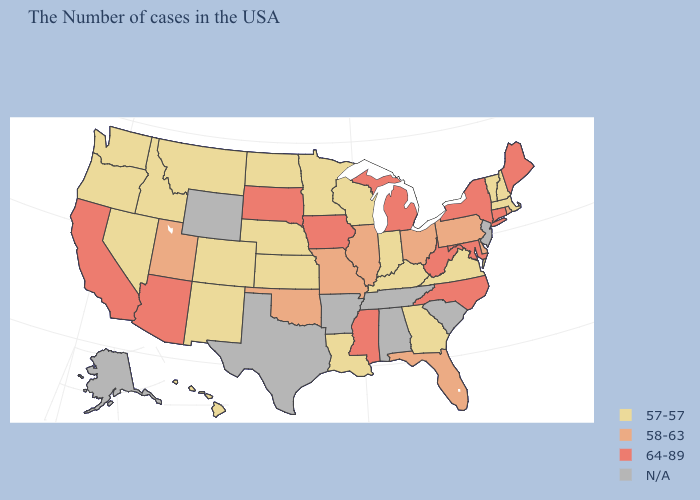Name the states that have a value in the range 64-89?
Answer briefly. Maine, Connecticut, New York, Maryland, North Carolina, West Virginia, Michigan, Mississippi, Iowa, South Dakota, Arizona, California. Name the states that have a value in the range N/A?
Concise answer only. New Jersey, South Carolina, Alabama, Tennessee, Arkansas, Texas, Wyoming, Alaska. What is the value of Minnesota?
Concise answer only. 57-57. Among the states that border Nebraska , does Colorado have the highest value?
Answer briefly. No. Does Montana have the highest value in the USA?
Quick response, please. No. What is the highest value in states that border New Hampshire?
Give a very brief answer. 64-89. Does Arizona have the highest value in the USA?
Quick response, please. Yes. Which states have the lowest value in the MidWest?
Be succinct. Indiana, Wisconsin, Minnesota, Kansas, Nebraska, North Dakota. What is the lowest value in the West?
Keep it brief. 57-57. Name the states that have a value in the range 58-63?
Quick response, please. Rhode Island, Delaware, Pennsylvania, Ohio, Florida, Illinois, Missouri, Oklahoma, Utah. What is the value of Maine?
Quick response, please. 64-89. Name the states that have a value in the range 64-89?
Quick response, please. Maine, Connecticut, New York, Maryland, North Carolina, West Virginia, Michigan, Mississippi, Iowa, South Dakota, Arizona, California. Which states have the lowest value in the West?
Short answer required. Colorado, New Mexico, Montana, Idaho, Nevada, Washington, Oregon, Hawaii. What is the value of Colorado?
Quick response, please. 57-57. Among the states that border California , which have the highest value?
Concise answer only. Arizona. 